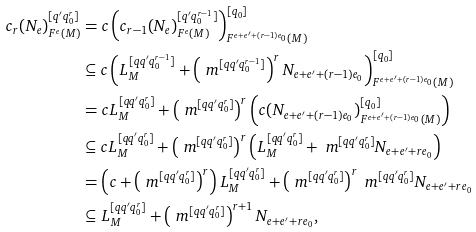<formula> <loc_0><loc_0><loc_500><loc_500>c _ { r } ( N _ { e } ) ^ { [ q ^ { \prime } q _ { 0 } ^ { r } ] } _ { F ^ { e } ( M ) } & = c \left ( c _ { r - 1 } ( N _ { e } ) ^ { [ q ^ { \prime } q _ { 0 } ^ { r - 1 } ] } _ { F ^ { e } ( M ) } \right ) ^ { [ q _ { 0 } ] } _ { F ^ { e + e ^ { \prime } + ( r - 1 ) e _ { 0 } } ( M ) } \\ & \subseteq c \left ( L ^ { [ q q ^ { \prime } q _ { 0 } ^ { r - 1 } ] } _ { M } + \left ( \ m ^ { [ q q ^ { \prime } q _ { 0 } ^ { r - 1 } ] } \right ) ^ { r } N _ { e + e ^ { \prime } + ( r - 1 ) e _ { 0 } } \right ) ^ { [ q _ { 0 } ] } _ { F ^ { e + e ^ { \prime } + ( r - 1 ) e _ { 0 } } ( M ) } \\ & = c L ^ { [ q q ^ { \prime } q _ { 0 } ^ { r } ] } _ { M } + \left ( \ m ^ { [ q q ^ { \prime } q _ { 0 } ^ { r } ] } \right ) ^ { r } \left ( c ( N _ { e + e ^ { \prime } + ( r - 1 ) e _ { 0 } } ) ^ { [ q _ { 0 } ] } _ { F ^ { e + e ^ { \prime } + ( r - 1 ) e _ { 0 } } ( M ) } \right ) \\ & \subseteq c L ^ { [ q q ^ { \prime } q _ { 0 } ^ { r } ] } _ { M } + \left ( \ m ^ { [ q q ^ { \prime } q _ { 0 } ^ { r } ] } \right ) ^ { r } \left ( L ^ { [ q q ^ { \prime } q _ { 0 } ^ { r } ] } _ { M } + \ m ^ { [ q q ^ { \prime } q _ { 0 } ^ { r } ] } N _ { e + e ^ { \prime } + r e _ { 0 } } \right ) \\ & = \left ( c + \left ( \ m ^ { [ q q ^ { \prime } q _ { 0 } ^ { r } ] } \right ) ^ { r } \right ) L ^ { [ q q ^ { \prime } q _ { 0 } ^ { r } ] } _ { M } + \left ( \ m ^ { [ q q ^ { \prime } q _ { 0 } ^ { r } ] } \right ) ^ { r } \ m ^ { [ q q ^ { \prime } q _ { 0 } ^ { r } ] } N _ { e + e ^ { \prime } + r e _ { 0 } } \\ & \subseteq L ^ { [ q q ^ { \prime } q _ { 0 } ^ { r } ] } _ { M } + \left ( \ m ^ { [ q q ^ { \prime } q _ { 0 } ^ { r } ] } \right ) ^ { r + 1 } N _ { e + e ^ { \prime } + r e _ { 0 } } ,</formula> 